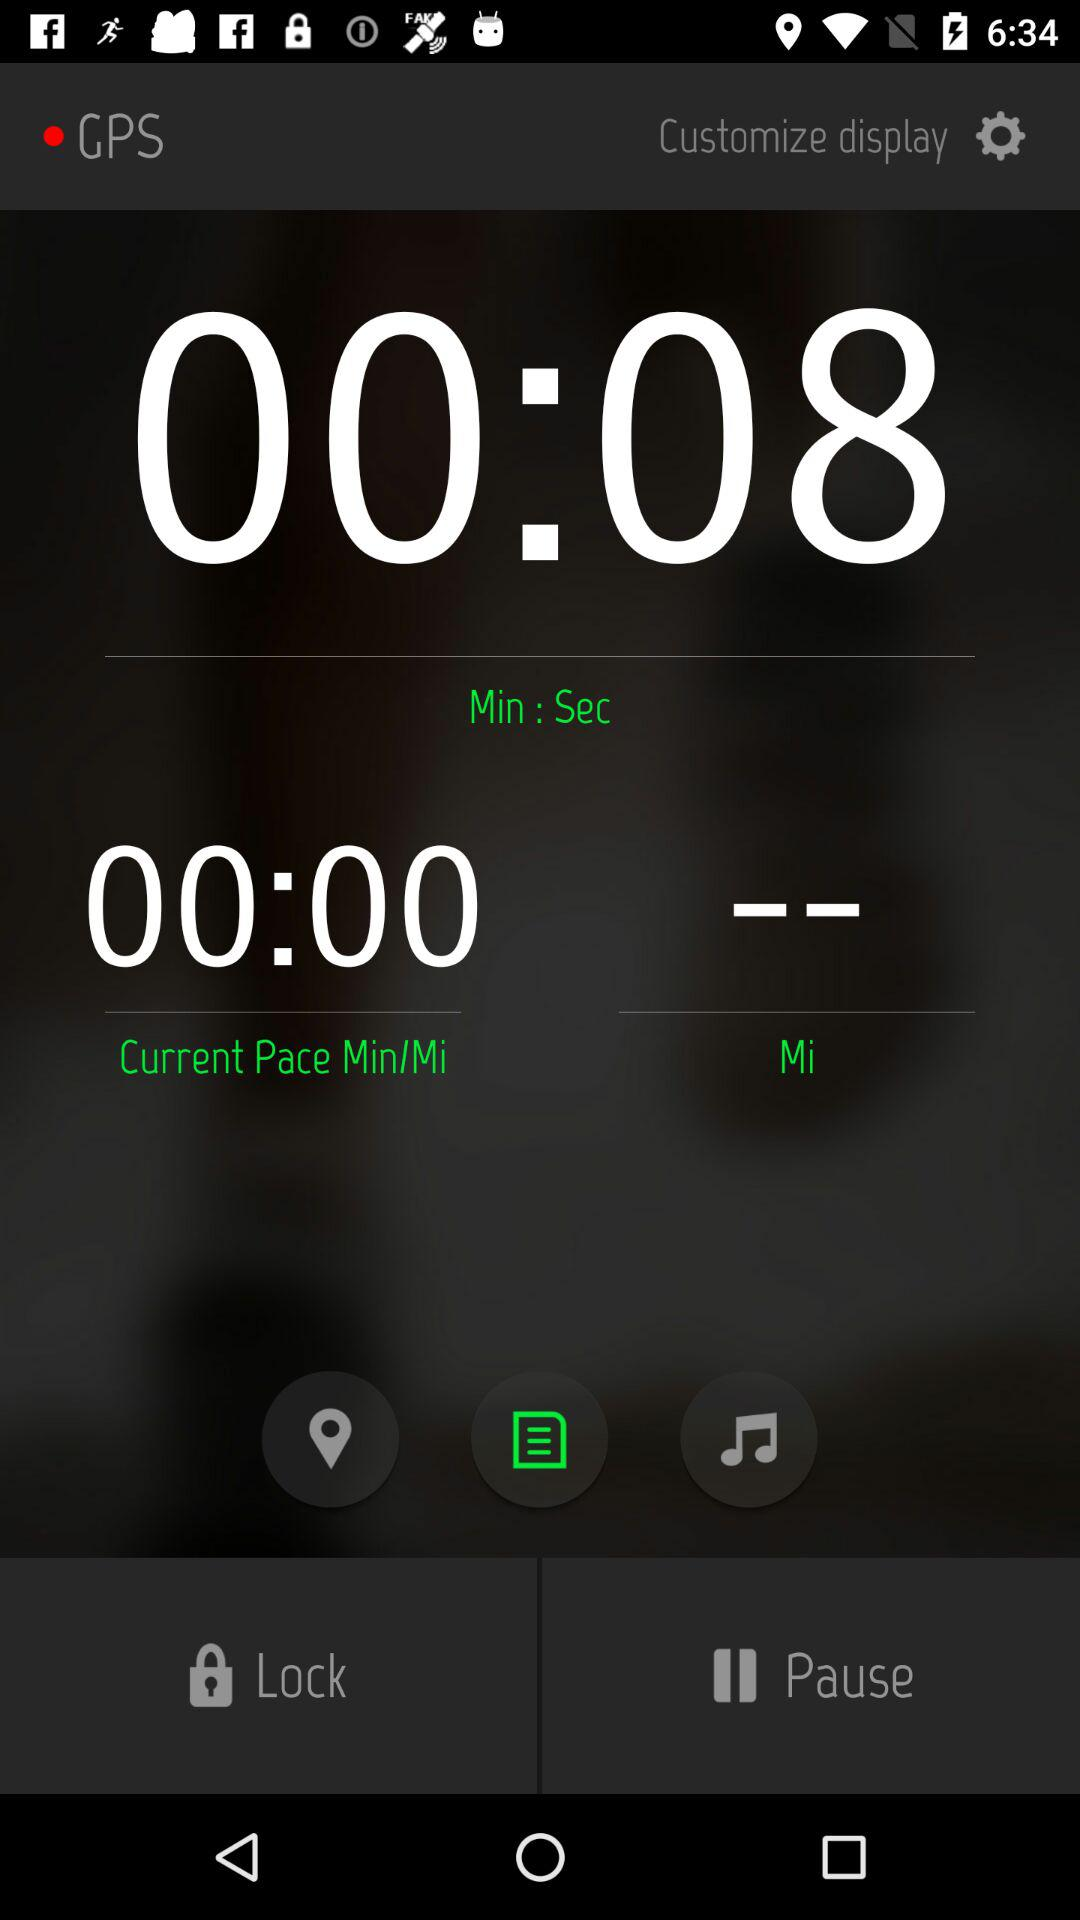How many seconds have elapsed?
Answer the question using a single word or phrase. 8 